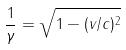<formula> <loc_0><loc_0><loc_500><loc_500>\frac { 1 } { \gamma } = \sqrt { 1 - ( v / c ) ^ { 2 } }</formula> 